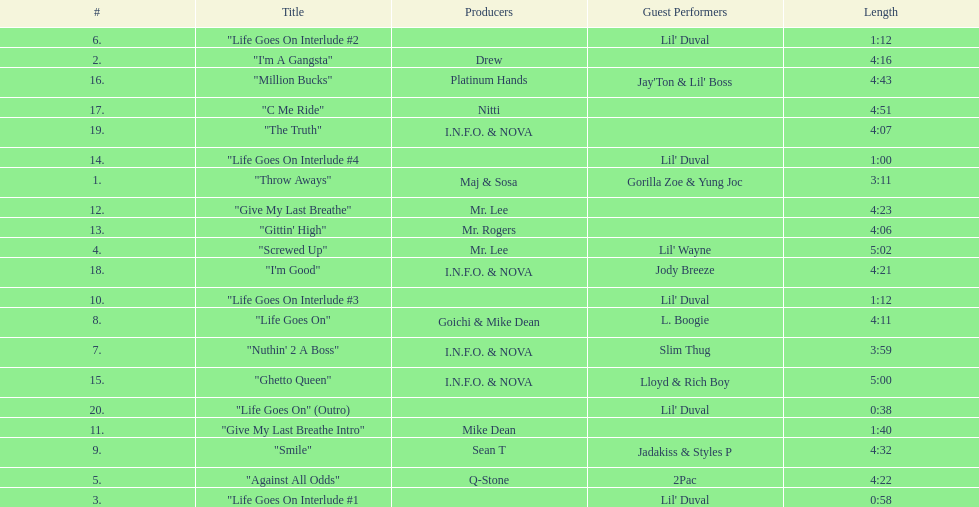How much time does the longest track on the album take? 5:02. 